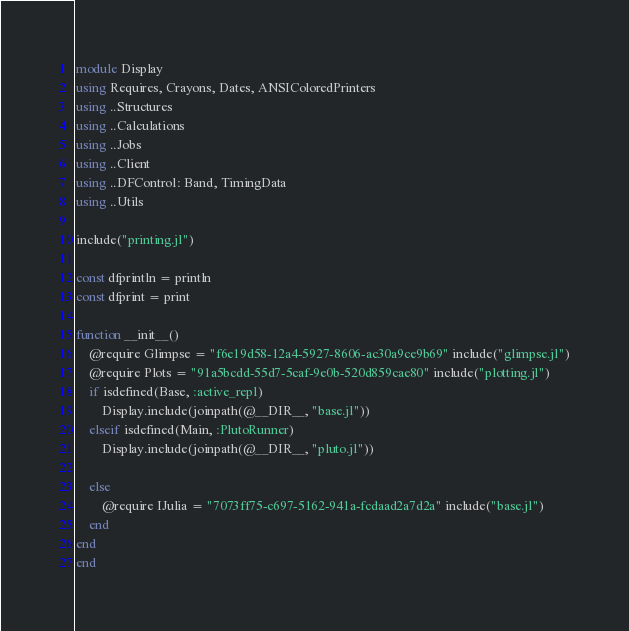Convert code to text. <code><loc_0><loc_0><loc_500><loc_500><_Julia_>module Display
using Requires, Crayons, Dates, ANSIColoredPrinters
using ..Structures
using ..Calculations
using ..Jobs
using ..Client
using ..DFControl: Band, TimingData
using ..Utils

include("printing.jl")

const dfprintln = println
const dfprint = print

function __init__()
    @require Glimpse = "f6e19d58-12a4-5927-8606-ac30a9ce9b69" include("glimpse.jl")
    @require Plots = "91a5bcdd-55d7-5caf-9e0b-520d859cae80" include("plotting.jl")
    if isdefined(Base, :active_repl)
        Display.include(joinpath(@__DIR__, "base.jl"))
    elseif isdefined(Main, :PlutoRunner)
        Display.include(joinpath(@__DIR__, "pluto.jl"))
        
    else
        @require IJulia = "7073ff75-c697-5162-941a-fcdaad2a7d2a" include("base.jl")
    end
end
end
</code> 